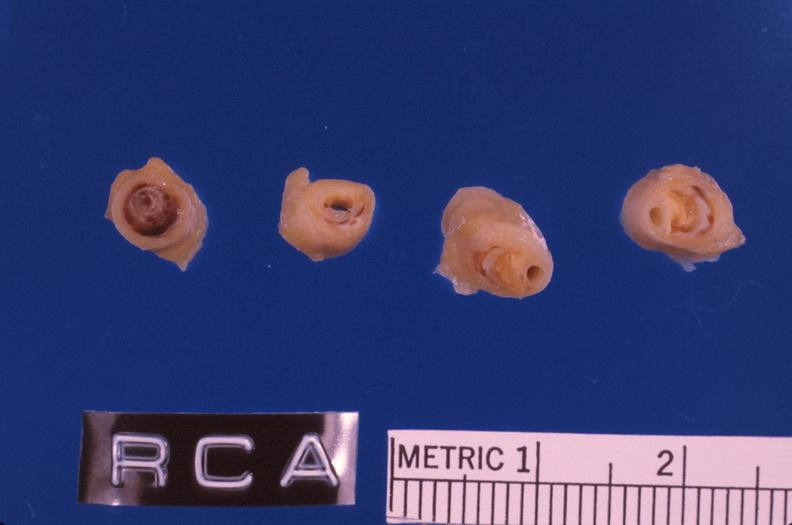where is this?
Answer the question using a single word or phrase. Vasculature 